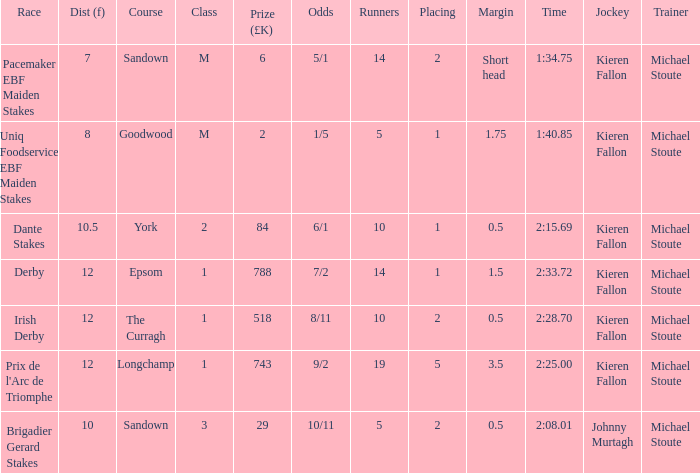Specify the smallest amount of runners achieving 1 10.0. 